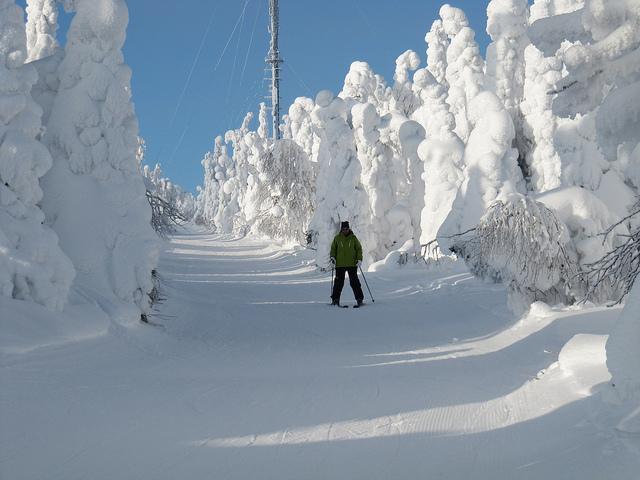How many people are skiing?
Give a very brief answer. 1. 